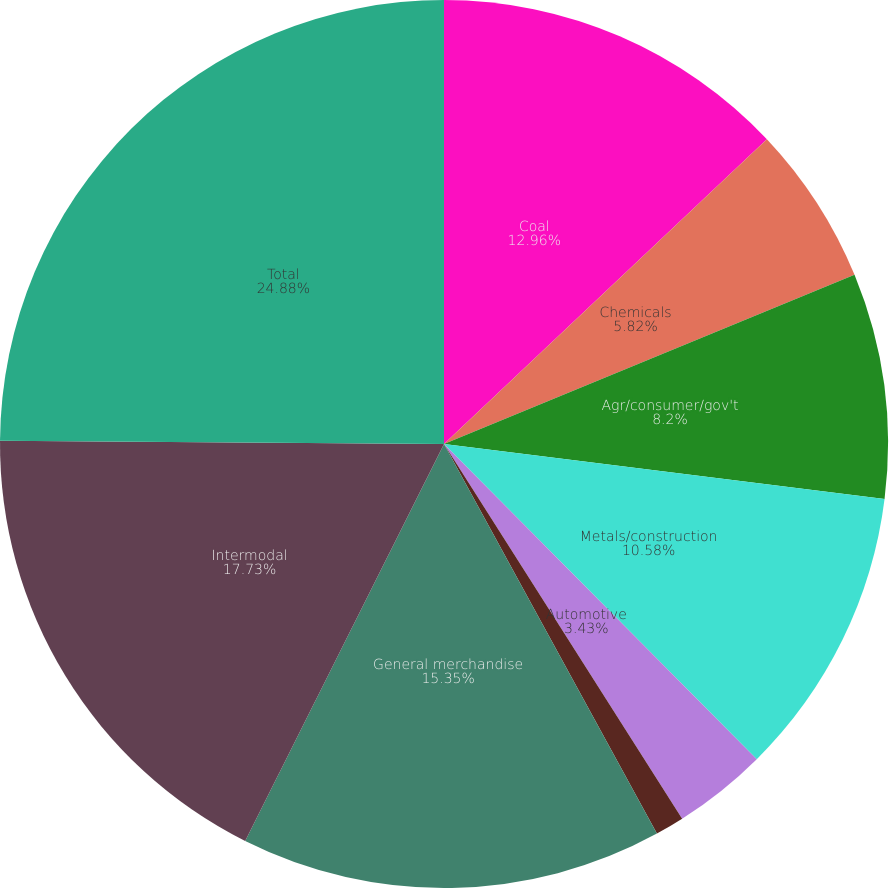<chart> <loc_0><loc_0><loc_500><loc_500><pie_chart><fcel>Coal<fcel>Chemicals<fcel>Agr/consumer/gov't<fcel>Metals/construction<fcel>Automotive<fcel>Paper/clay/forest<fcel>General merchandise<fcel>Intermodal<fcel>Total<nl><fcel>12.96%<fcel>5.82%<fcel>8.2%<fcel>10.58%<fcel>3.43%<fcel>1.05%<fcel>15.35%<fcel>17.73%<fcel>24.88%<nl></chart> 